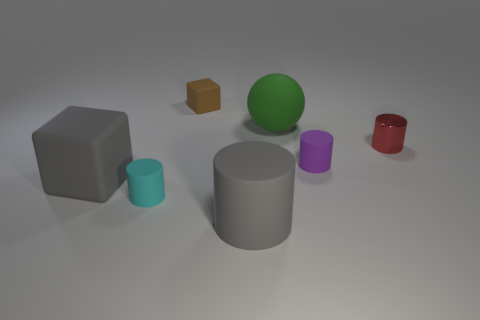Can you describe the shapes and colors visible in the image? Certainly, the image depicts a variety of geometric shapes. There's a large grey matte cube, a smaller brown cube, a large green sphere, a small turquoise cylinder, a large grey cylinder, a small purple cylinder, and a small red cup-shaped object. Which object stands out the most based on its size? The large grey matte cube stands out due to its substantial size compared to the other objects in the image. 